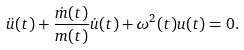<formula> <loc_0><loc_0><loc_500><loc_500>\ddot { u } ( t ) + \frac { \dot { m } ( t ) } { m ( t ) } \dot { u } ( t ) + \omega ^ { 2 } ( t ) u ( t ) = 0 .</formula> 